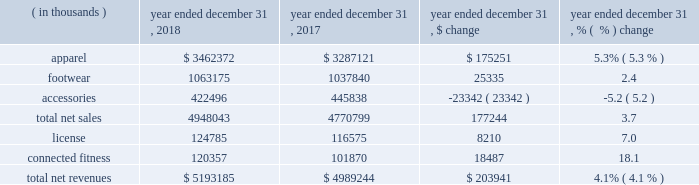Consolidated results of operations year ended december 31 , 2018 compared to year ended december 31 , 2017 net revenues increased $ 203.9 million , or 4.1% ( 4.1 % ) , to $ 5193.2 million in 2018 from $ 4989.2 million in 2017 .
Net revenues by product category are summarized below: .
The increase in net sales was driven primarily by : 2022 apparel unit sales growth driven by the train category ; and 2022 footwear unit sales growth , led by the run category .
The increase was partially offset by unit sales decline in accessories .
License revenues increased $ 8.2 million , or 7.0% ( 7.0 % ) , to $ 124.8 million in 2018 from $ 116.6 million in 2017 .
Connected fitness revenue increased $ 18.5 million , or 18.1% ( 18.1 % ) , to $ 120.4 million in 2018 from $ 101.9 million in 2017 primarily driven by increased subscribers on our fitness applications .
Gross profit increased $ 89.1 million to $ 2340.5 million in 2018 from $ 2251.4 million in 2017 .
Gross profit as a percentage of net revenues , or gross margin , was unchanged at 45.1% ( 45.1 % ) in 2018 compared to 2017 .
Gross profit percentage was favorably impacted by lower promotional activity , improvements in product cost , lower air freight , higher proportion of international and connected fitness revenue and changes in foreign currency ; these favorable impacts were offset by channel mix including higher sales to our off-price channel and restructuring related charges .
With the exception of improvements in product input costs and air freight improvements , we do not expect these trends to have a material impact on the full year 2019 .
Selling , general and administrative expenses increased $ 82.8 million to $ 2182.3 million in 2018 from $ 2099.5 million in 2017 .
As a percentage of net revenues , selling , general and administrative expenses decreased slightly to 42.0% ( 42.0 % ) in 2018 from 42.1% ( 42.1 % ) in 2017 .
Selling , general and administrative expense was impacted by the following : 2022 marketing costs decreased $ 21.3 million to $ 543.8 million in 2018 from $ 565.1 million in 2017 .
This decrease was primarily due to restructuring efforts , resulting in lower compensation and contractual sports marketing .
This decrease was partially offset by higher costs in connection with brand marketing campaigns and increased marketing investments with the growth of our international business .
As a percentage of net revenues , marketing costs decreased to 10.5% ( 10.5 % ) in 2018 from 11.3% ( 11.3 % ) in 2017 .
2022 other costs increased $ 104.1 million to $ 1638.5 million in 2018 from $ 1534.4 million in 2017 .
This increase was primarily due to higher incentive compensation expense and higher costs incurred for the continued expansion of our direct to consumer distribution channel and international business .
As a percentage of net revenues , other costs increased to 31.6% ( 31.6 % ) in 2018 from 30.8% ( 30.8 % ) in 2017 .
Restructuring and impairment charges increased $ 59.1 million to $ 183.1 million from $ 124.0 million in 2017 .
Refer to the restructuring plans section above for a summary of charges .
Income ( loss ) from operations decreased $ 52.8 million , or 189.9% ( 189.9 % ) , to a loss of $ 25.0 million in 2018 from income of $ 27.8 million in 2017 .
As a percentage of net revenues , income from operations decreased to a loss of 0.4% ( 0.4 % ) in 2018 from income of 0.5% ( 0.5 % ) in 2017 .
Income from operations for the year ended december 31 , 2018 was negatively impacted by $ 203.9 million of restructuring , impairment and related charges in connection with the 2018 restructuring plan .
Income from operations for the year ended december 31 , 2017 was negatively impacted by $ 129.1 million of restructuring , impairment and related charges in connection with the 2017 restructuring plan .
Interest expense , net decreased $ 0.9 million to $ 33.6 million in 2018 from $ 34.5 million in 2017. .
What was connected fitness as a percentage of total net revenue in 2018? 
Computations: (120357 / 5193185)
Answer: 0.02318. 